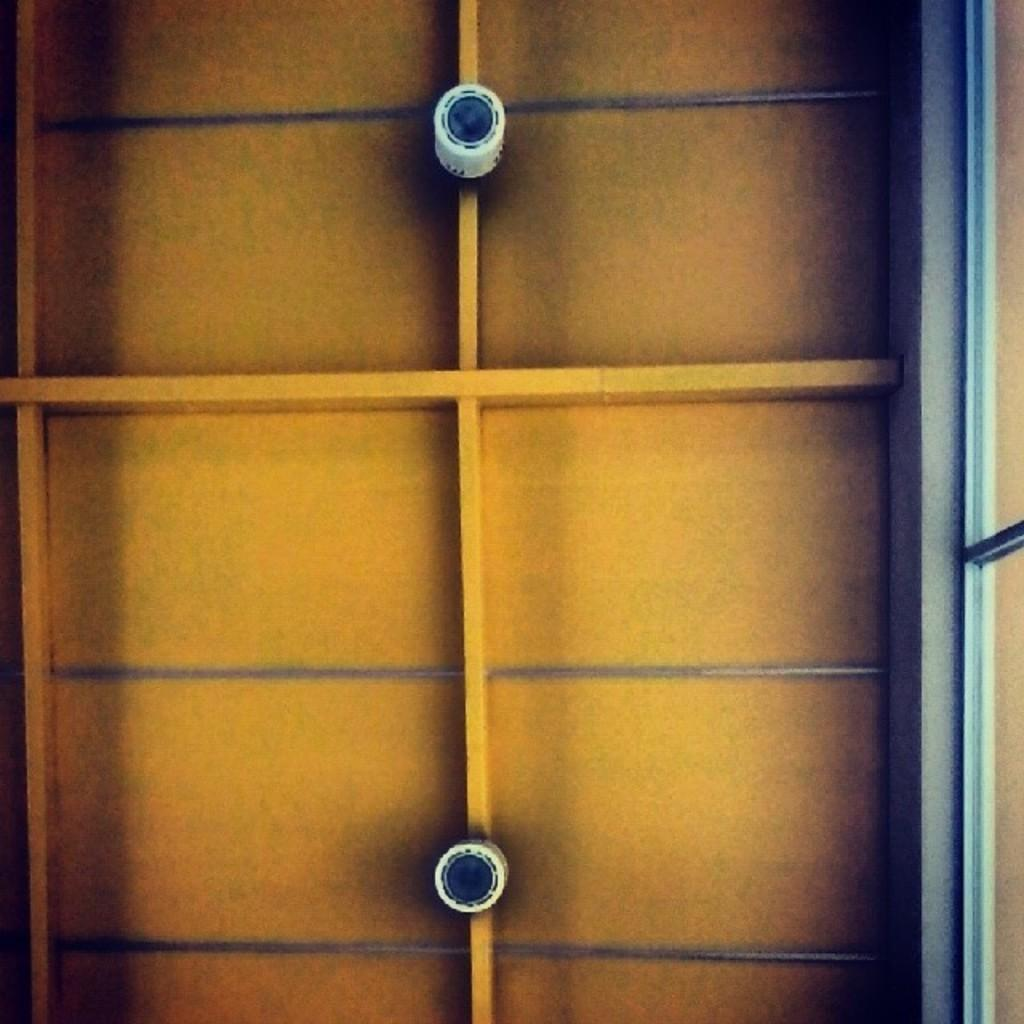What type of furniture is present in the image? The image contains a wooden shelf. Can you tell me who won the argument that took place on the wooden shelf in the image? There is no indication of an argument or any people present in the image; it only features a wooden shelf. 